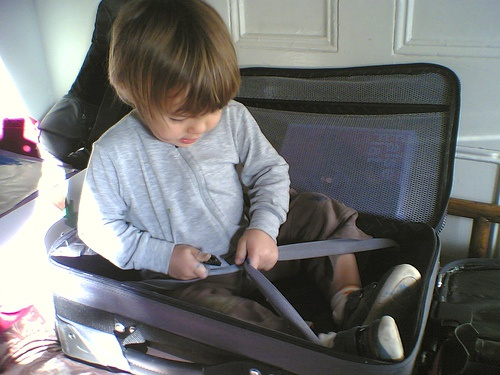Describe the objects in this image and their specific colors. I can see people in gray, black, darkgray, and lightgray tones and suitcase in gray, black, and white tones in this image. 